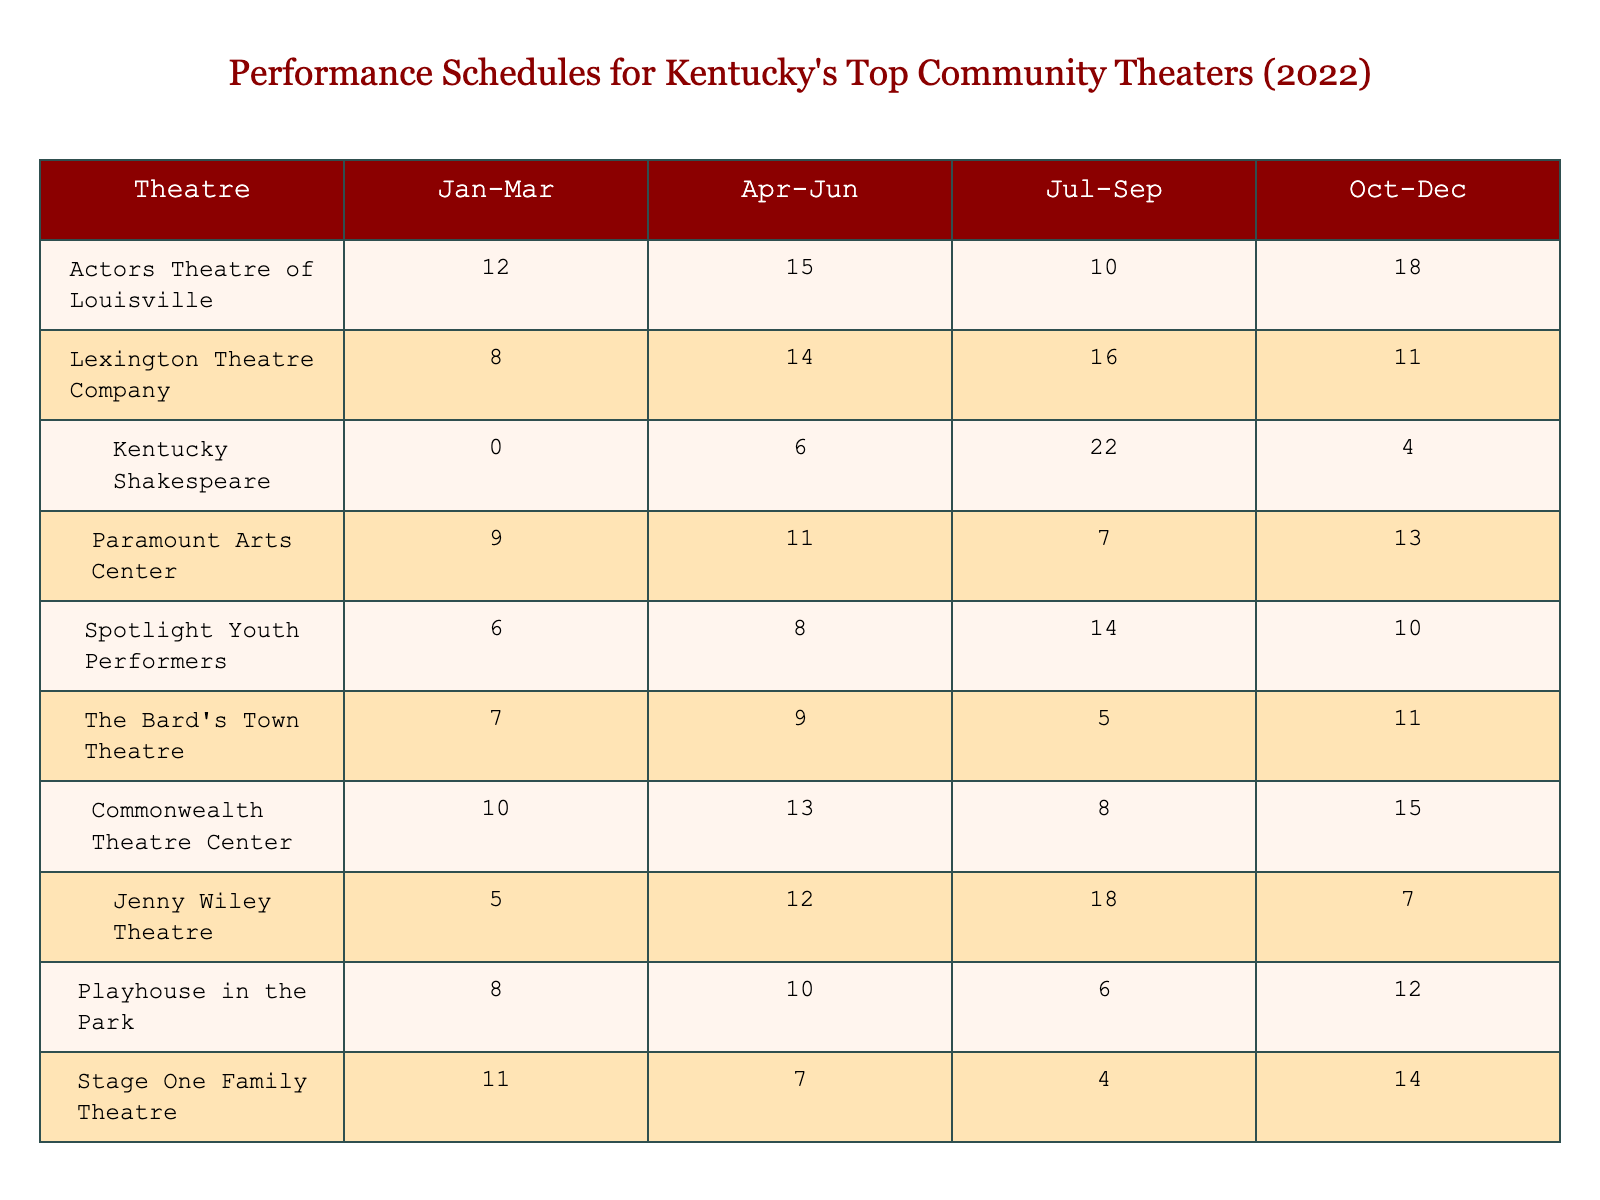What community theater had the highest number of performances in the Jan-Mar quarter? By looking at the "Jan-Mar" column, we can identify the highest value. Actors Theatre of Louisville has 12 performances, which is the highest among all listed theaters for that quarter.
Answer: Actors Theatre of Louisville Which community theater performed the least in the Jul-Sep quarter? From the "Jul-Sep" column, we see that Kentucky Shakespeare had the least number of performances with 22, which is also the highest among the options. Therefore, the answer is Paramount Arts Center with just 7 performances.
Answer: Paramount Arts Center What is the total number of performances for the Spotlight Youth Performers across all quarters? To find the total, we sum the values in the row for Spotlight Youth Performers: 6 + 8 + 14 + 10 = 38.
Answer: 38 Which quarter had the highest overall total of performances across all theaters? We need to add the numbers for each quarter: Jan-Mar (12 + 8 + 0 + 9 + 6 + 7 + 10 + 5 + 8 + 11 = 76), Apr-Jun (15 + 14 + 6 + 11 + 8 + 9 + 13 + 12 + 10 + 7 = 75), Jul-Sep (10 + 16 + 22 + 7 + 14 + 5 + 8 + 18 + 6 + 4 = 118), Oct-Dec (18 + 11 + 4 + 13 + 10 + 11 + 15 + 7 + 12 + 14 = 121). The highest total is in Oct-Dec with 121 performances.
Answer: Oct-Dec What is the average number of performances for Kentucky Shakespeare throughout the year? Total performances for Kentucky Shakespeare: 0 + 6 + 22 + 4 = 32. To find the average, we divide by the number of quarters: 32/4 = 8.
Answer: 8 Did any theater have the same number of performances in two different quarters? Going through the data, we check for any equal values in the same row across quarters. We find that Playhouse in the Park has 10 performances in both Apr-Jun and Oct-Dec.
Answer: Yes Which theater had the most performances overall in 2022? We sum up the performances for each theater: Actors Theatre of Louisville (55), Lexington Theatre Company (49), Kentucky Shakespeare (32), Paramount Arts Center (40), Spotlight Youth Performers (38), The Bard's Town Theatre (32), Commonwealth Theatre Center (46), Jenny Wiley Theatre (42), Playhouse in the Park (36), Stage One Family Theatre (36). The highest is Actors Theatre of Louisville with 55 performances.
Answer: Actors Theatre of Louisville In the Apr-Jun quarter, what was the average number of performances across all theaters? We sum the performances for Apr-Jun: 15 + 14 + 6 + 11 + 8 + 9 + 13 + 12 + 10 + 7 = 75. There are 10 theaters, so we divide 75 by 10. The average is 7.5.
Answer: 7.5 Which theater had the largest increase in performances from Jan-Mar to Jul-Sep? Checking the values, we find Actors Theatre of Louisville increased from 12 in Jan-Mar to 10 in Jul-Sep, Kentucky Shakespeare increased from 0 to 22, Paramount Arts Center went from 9 to 7, and Spotlight Youth Performers went from 6 to 14. The largest increase is Kentucky Shakespeare by 22 performances.
Answer: Kentucky Shakespeare Were there any theaters that had a consistent number of performances across all four quarters? By reviewing each row for consistent numbers, we find none have the same performances across all quarters. Each theater varied in at least one quarter.
Answer: No 